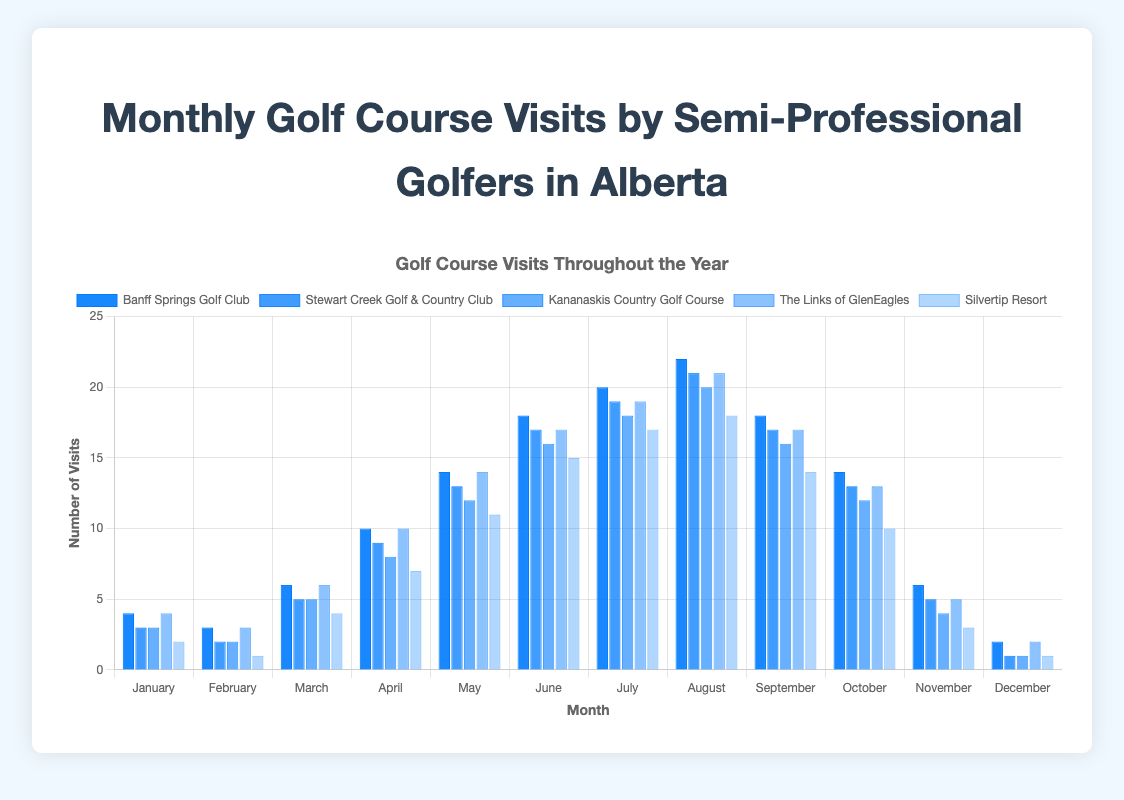How many total visits were made to Banff Springs Golf Club in July? To find the total visits in July for Banff Springs Golf Club, we look at the data for that month. The chart shows 20 visits in July.
Answer: 20 Which golf course had the highest number of visits in October? To determine which golf course had the highest visits in October, we compare the values for each course. Banff Springs Golf Club had 14 visits, which is the highest among all the courses.
Answer: Banff Springs Golf Club Compare the number of visits in August between Banff Springs Golf Club and Stewart Creek Golf & Country Club. Which one is greater and by how much? Banff Springs Golf Club had 22 visits in August, whereas Stewart Creek Golf & Country Club had 21 visits. The difference is 22 - 21 = 1 visit.
Answer: Banff Springs Golf Club, by 1 visit What is the average number of visits for Kananaskis Country Golf Course in the first quarter (January to March)? Sum the visits for January, February, and March: 3 + 2 + 5 = 10. Then, divide by 3 months to find the average: 10 / 3 ≈ 3.33.
Answer: 3.33 How many more visits were made to The Links of GlenEagles in May compared to Silvertip Resort? The Links of GlenEagles had 14 visits in May and Silvertip Resort had 11 visits. The difference is 14 - 11 = 3 visits.
Answer: 3 visits What is the total number of visits across all golf courses in December? Sum the December visits for all courses: 2 + 1 + 1 + 2 + 1 = 7.
Answer: 7 Visually, which month generally had the lowest number of visits across all courses? Checking the chart's bar heights across all months, January and December seem to have the shortest bars overall. Between January and December, December has lower bars.
Answer: December How many visits did Stewart Creek Golf & Country Club have in total from June to August? Sum the visits for Stewart Creek Golf & Country Club in June, July, and August: 17 + 19 + 21 = 57.
Answer: 57 Was there an increase or decrease in visits to Silvertip Resort from February to March, and by how much? The number of visits in February was 1 and in March was 4. An increase occurred: 4 - 1 = 3 visits.
Answer: Increase, by 3 visits For each golf course, was the number of visits in November greater than the number of visits in February? Comparing November and February for each course: Banff Springs (6 > 3), Stewart Creek (5 > 2), Kananaskis (4 > 2), GlenEagles (5 > 3), Silvertip (3 > 1). Each had more visits in November than in February.
Answer: Yes, for all courses 